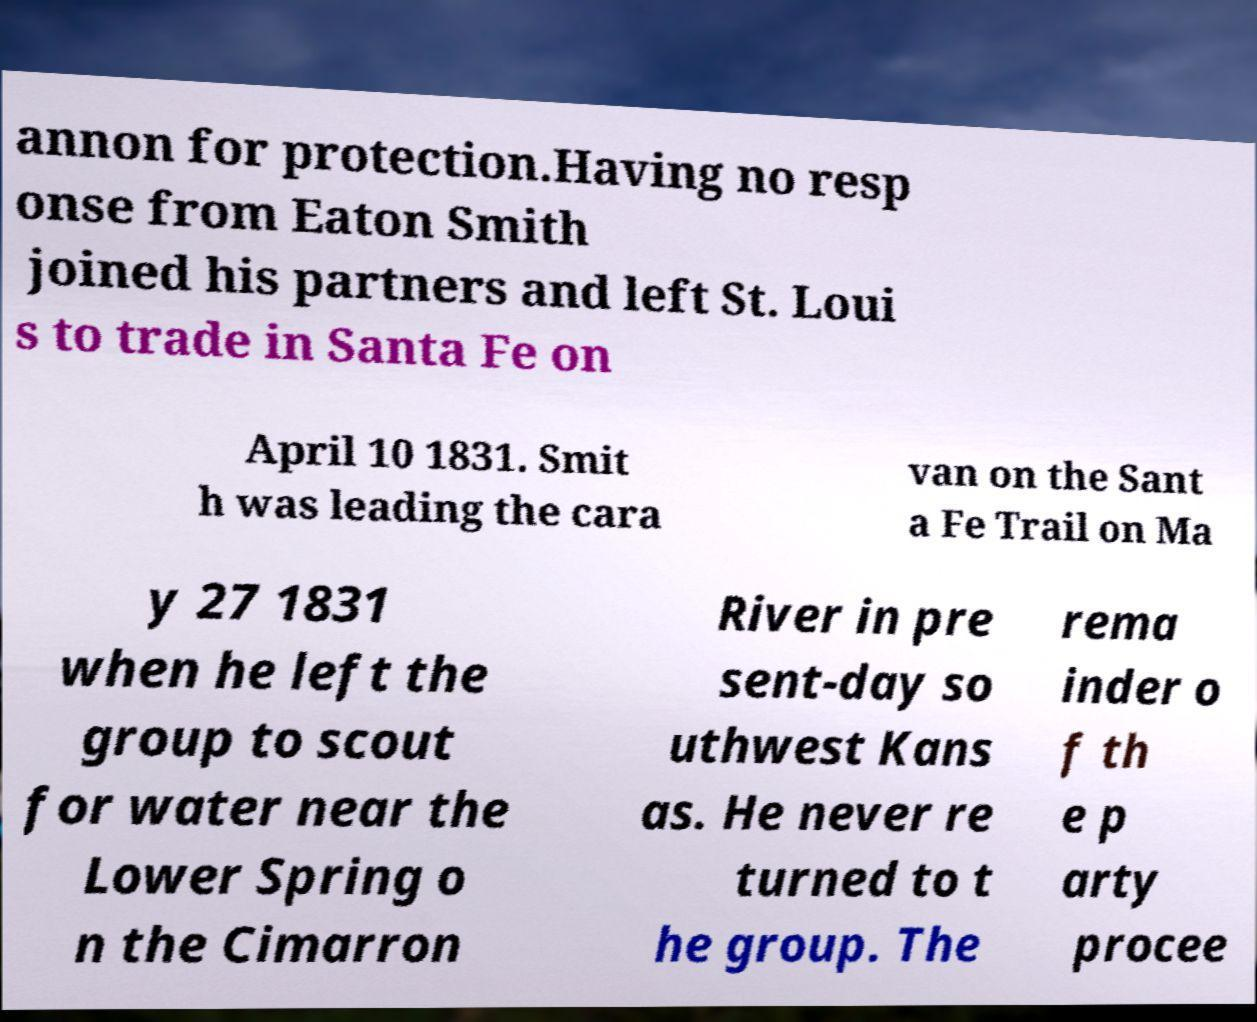What messages or text are displayed in this image? I need them in a readable, typed format. annon for protection.Having no resp onse from Eaton Smith joined his partners and left St. Loui s to trade in Santa Fe on April 10 1831. Smit h was leading the cara van on the Sant a Fe Trail on Ma y 27 1831 when he left the group to scout for water near the Lower Spring o n the Cimarron River in pre sent-day so uthwest Kans as. He never re turned to t he group. The rema inder o f th e p arty procee 